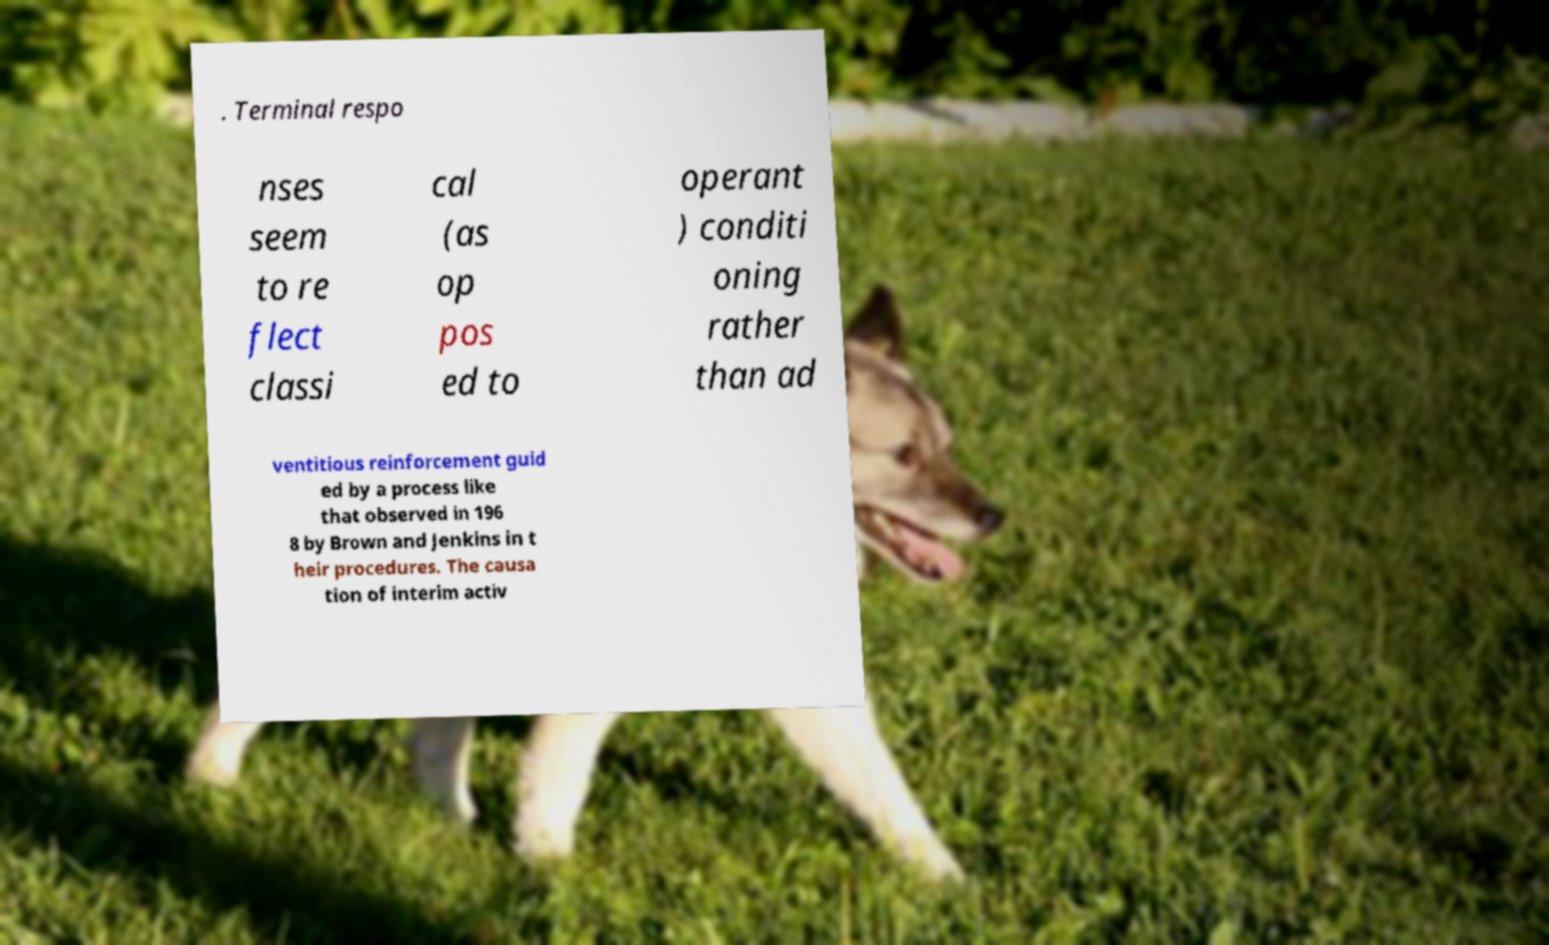Can you accurately transcribe the text from the provided image for me? . Terminal respo nses seem to re flect classi cal (as op pos ed to operant ) conditi oning rather than ad ventitious reinforcement guid ed by a process like that observed in 196 8 by Brown and Jenkins in t heir procedures. The causa tion of interim activ 